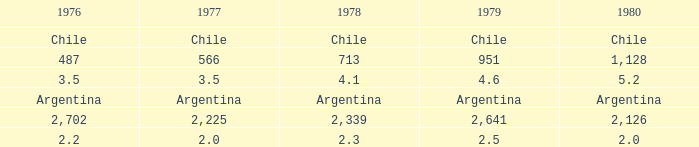What is 1980 when 1979 is 951? 1128.0. Could you parse the entire table? {'header': ['1976', '1977', '1978', '1979', '1980'], 'rows': [['Chile', 'Chile', 'Chile', 'Chile', 'Chile'], ['487', '566', '713', '951', '1,128'], ['3.5', '3.5', '4.1', '4.6', '5.2'], ['Argentina', 'Argentina', 'Argentina', 'Argentina', 'Argentina'], ['2,702', '2,225', '2,339', '2,641', '2,126'], ['2.2', '2.0', '2.3', '2.5', '2.0']]} 